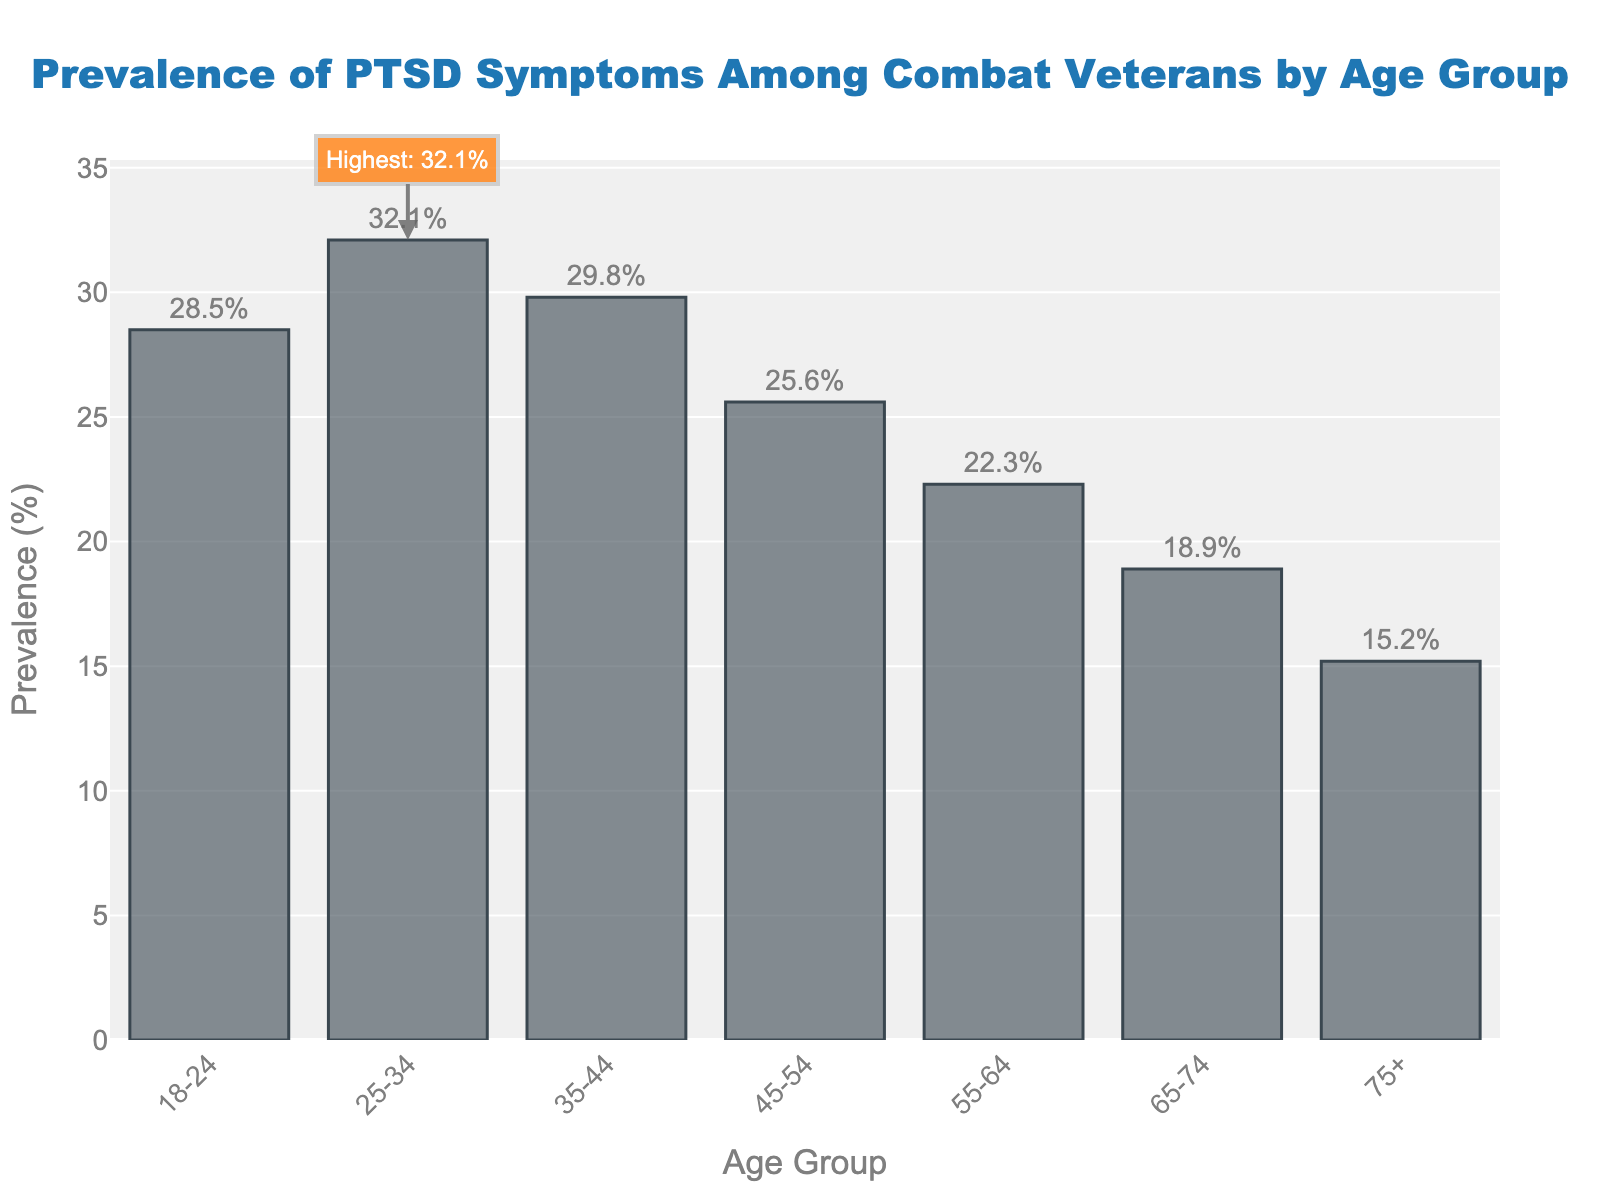Which age group has the highest prevalence of PTSD symptoms? The figure highlights the age group 25-34 as having the highest prevalence with an annotation and a bar marked distinctly from the others.
Answer: 25-34 What is the prevalence difference between the 25-34 and 75+ age groups? The figure shows the prevalence of the 25-34 age group is 32.1% and the 75+ age group is 15.2%. The difference is calculated as 32.1% - 15.2% = 16.9%.
Answer: 16.9% Which age group has the lowest prevalence of PTSD symptoms? By examining the heights of the bars, the bar representing the 75+ age group is the shortest, indicating the lowest prevalence at 15.2%.
Answer: 75+ Is the prevalence among the 45-54 age group higher or lower than that of the 55-64 age group? The bar for the 45-54 age group is higher than the bar for the 55-64 age group. Specifically, 25.6% is higher than 22.3%.
Answer: Higher How much higher is the prevalence in the 35-44 age group compared to the 65-74 age group? The figure shows the prevalence for the 35-44 age group is 29.8% and for the 65-74 age group it is 18.9%. The difference is computed as 29.8% - 18.9% = 10.9%.
Answer: 10.9% What is the combined prevalence of the age groups 18-24 and 45-54? The figure lists the prevalence for the 18-24 age group at 28.5% and the 45-54 age group at 25.6%. Adding these together: 28.5% + 25.6% = 54.1%.
Answer: 54.1% Which age group has a prevalence rate closest to 30%? By comparing the prevalence values, the 35-44 age group has a prevalence rate of 29.8%, which is closest to 30%.
Answer: 35-44 How does the prevalence of PTSD symptoms change from the 55-64 age group to the 75+ age group? The prevalence decreases from 22.3% in the 55-64 age group to 15.2% in the 75+ age group, indicating a downward trend.
Answer: Decreasing What is the average prevalence rate of all the age groups? Summing the prevalence rates (28.5 + 32.1 + 29.8 + 25.6 + 22.3 + 18.9 + 15.2) and dividing by the number of groups (7), we get (172.4 / 7) = 24.63%.
Answer: 24.63% Are there more age groups with a prevalence above or below 25%? Counting the bars above 25% (18-24, 25-34, 35-44) gives 3 age groups. Counting the bars below 25% (45-54, 55-64, 65-74, 75+) gives 4 age groups, hence more age groups are below 25%.
Answer: Below 